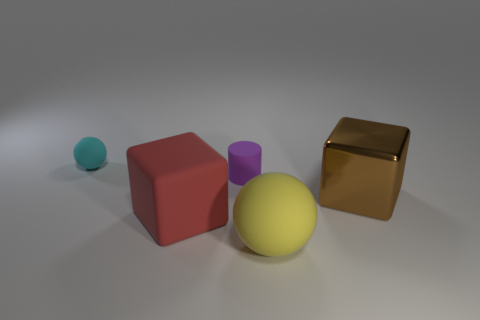What is the shape of the matte thing that is on the right side of the red matte cube and behind the red block?
Offer a terse response. Cylinder. What material is the ball that is in front of the rubber ball that is left of the yellow object made of?
Your answer should be compact. Rubber. Is the material of the big sphere on the right side of the red matte cube the same as the red object?
Your answer should be very brief. Yes. How big is the sphere behind the red cube?
Your answer should be very brief. Small. Are there any brown blocks that are to the right of the cube right of the tiny purple thing?
Provide a short and direct response. No. There is a big thing on the right side of the big ball; does it have the same color as the large thing that is to the left of the cylinder?
Offer a very short reply. No. What color is the big sphere?
Your response must be concise. Yellow. Is there anything else that has the same color as the large metallic cube?
Ensure brevity in your answer.  No. There is a thing that is both on the left side of the purple matte cylinder and in front of the cyan object; what color is it?
Offer a very short reply. Red. There is a block to the left of the purple rubber cylinder; is its size the same as the big yellow object?
Your answer should be very brief. Yes. 